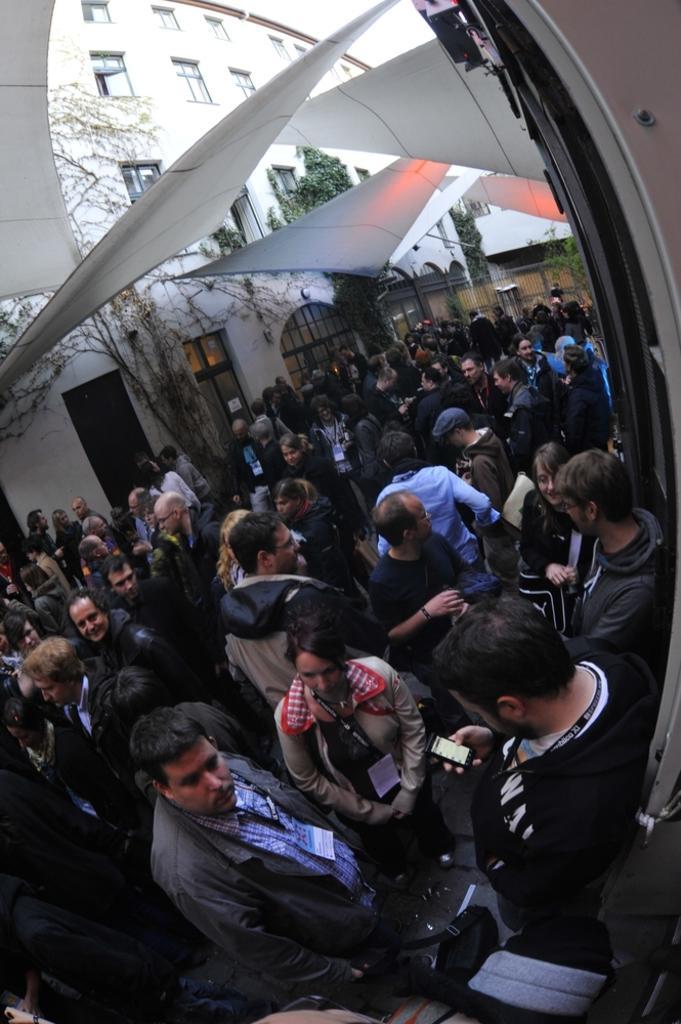In one or two sentences, can you explain what this image depicts? In this image we can see so many people are standing. Background of the image white color building is there and trees are present. 